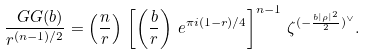<formula> <loc_0><loc_0><loc_500><loc_500>\frac { \ G G ( b ) } { r ^ { ( n - 1 ) / 2 } } = \left ( \frac { n } { r } \right ) \, \left [ \left ( \frac { b } { r } \right ) \, e ^ { \pi i ( 1 - r ) / 4 } \right ] ^ { n - 1 } \, \zeta ^ { ( - \frac { b | \rho | ^ { 2 } } { 2 } ) ^ { \vee } } .</formula> 